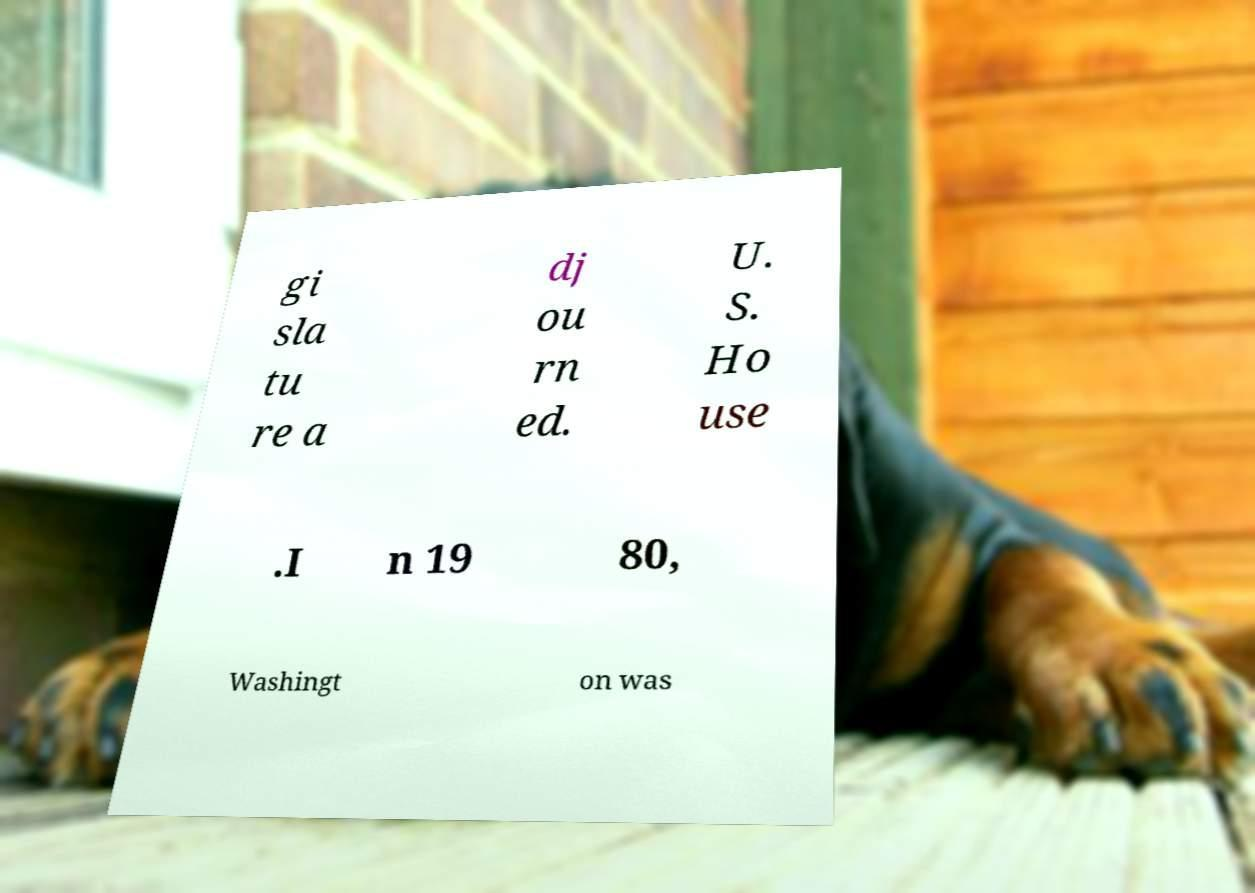Could you assist in decoding the text presented in this image and type it out clearly? gi sla tu re a dj ou rn ed. U. S. Ho use .I n 19 80, Washingt on was 